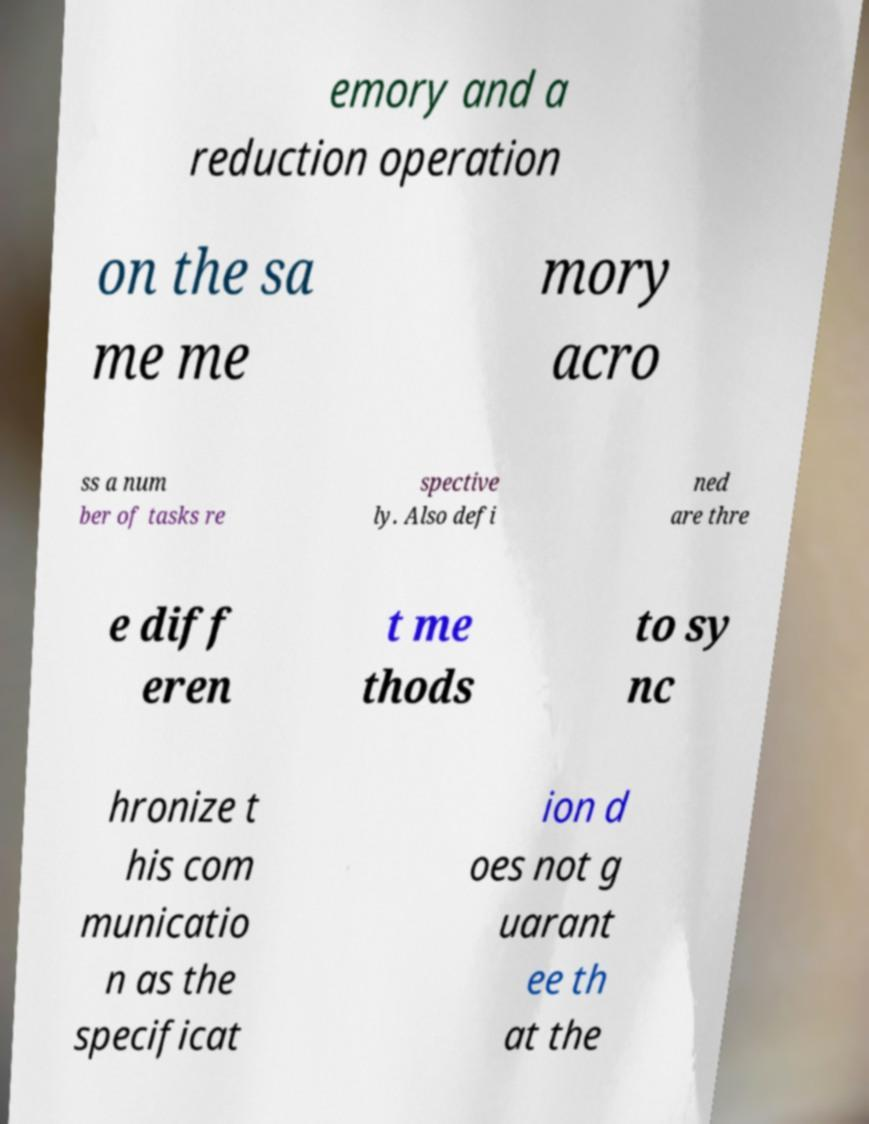Could you extract and type out the text from this image? emory and a reduction operation on the sa me me mory acro ss a num ber of tasks re spective ly. Also defi ned are thre e diff eren t me thods to sy nc hronize t his com municatio n as the specificat ion d oes not g uarant ee th at the 